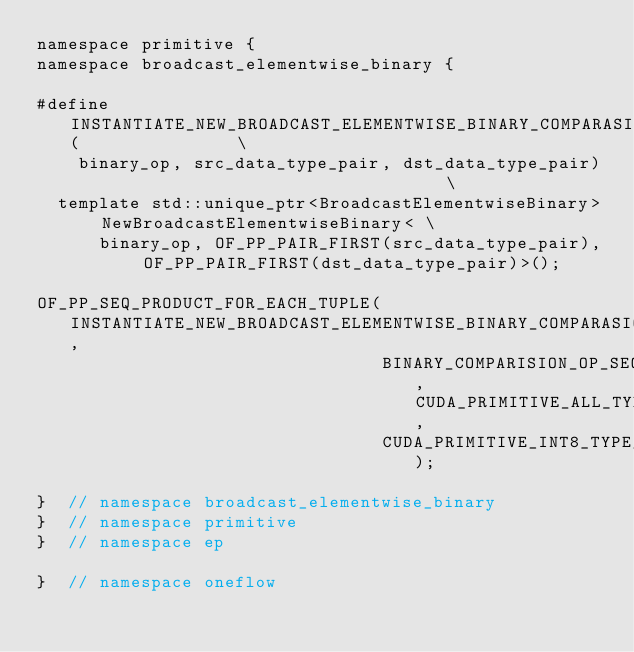Convert code to text. <code><loc_0><loc_0><loc_500><loc_500><_Cuda_>namespace primitive {
namespace broadcast_elementwise_binary {

#define INSTANTIATE_NEW_BROADCAST_ELEMENTWISE_BINARY_COMPARASION_ENTRY(               \
    binary_op, src_data_type_pair, dst_data_type_pair)                                \
  template std::unique_ptr<BroadcastElementwiseBinary> NewBroadcastElementwiseBinary< \
      binary_op, OF_PP_PAIR_FIRST(src_data_type_pair), OF_PP_PAIR_FIRST(dst_data_type_pair)>();

OF_PP_SEQ_PRODUCT_FOR_EACH_TUPLE(INSTANTIATE_NEW_BROADCAST_ELEMENTWISE_BINARY_COMPARASION_ENTRY,
                                 BINARY_COMPARISION_OP_SEQ, CUDA_PRIMITIVE_ALL_TYPE_SEQ,
                                 CUDA_PRIMITIVE_INT8_TYPE_SEQ);

}  // namespace broadcast_elementwise_binary
}  // namespace primitive
}  // namespace ep

}  // namespace oneflow
</code> 